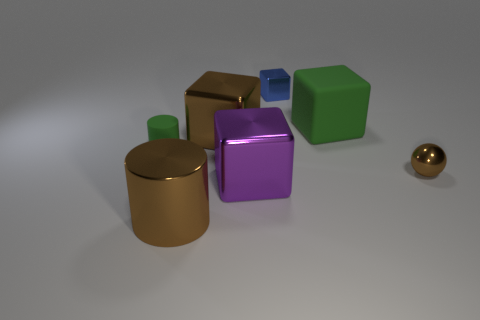How many big cubes are to the right of the tiny metallic object that is behind the large green block?
Provide a short and direct response. 1. How many other objects are the same material as the tiny cylinder?
Your answer should be very brief. 1. Does the green object left of the tiny blue cube have the same material as the large block on the right side of the purple metal object?
Provide a short and direct response. Yes. Is there any other thing that has the same shape as the small brown object?
Ensure brevity in your answer.  No. Does the large purple object have the same material as the tiny thing behind the small cylinder?
Give a very brief answer. Yes. What is the color of the big shiny thing that is behind the green object that is on the left side of the green thing on the right side of the small green object?
Offer a terse response. Brown. There is a brown thing that is the same size as the blue block; what is its shape?
Provide a short and direct response. Sphere. Is there anything else that has the same size as the green matte cube?
Keep it short and to the point. Yes. Does the brown thing that is behind the tiny brown sphere have the same size as the cube behind the big matte block?
Offer a very short reply. No. There is a cylinder that is in front of the tiny green cylinder; what is its size?
Offer a very short reply. Large. 